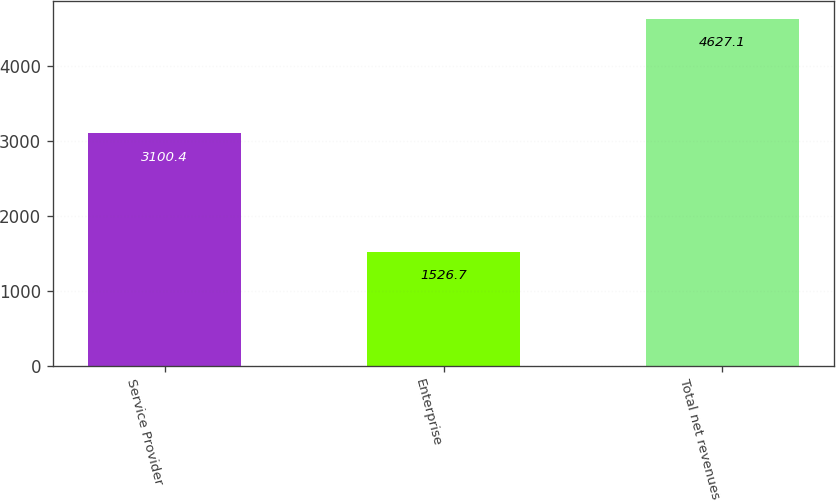<chart> <loc_0><loc_0><loc_500><loc_500><bar_chart><fcel>Service Provider<fcel>Enterprise<fcel>Total net revenues<nl><fcel>3100.4<fcel>1526.7<fcel>4627.1<nl></chart> 